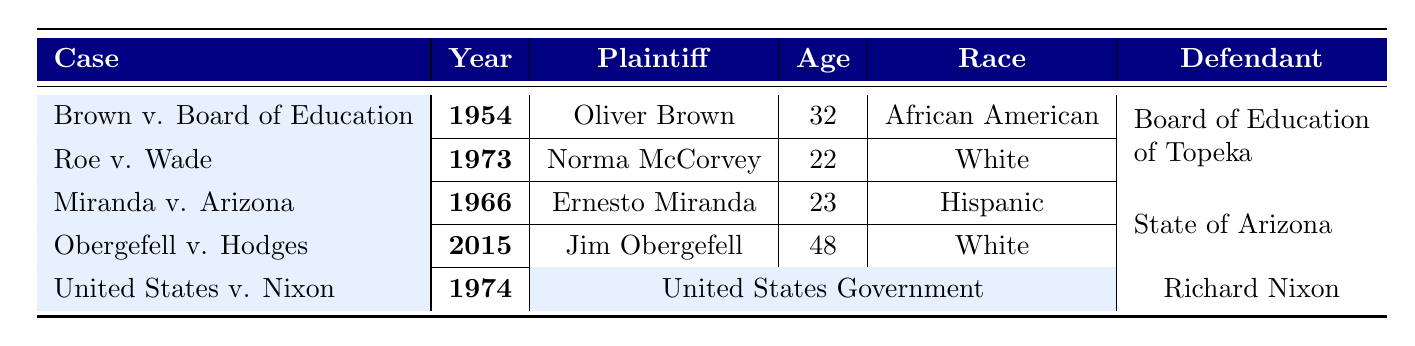What is the age of the plaintiff in Brown v. Board of Education? The table indicates Oliver Brown is the plaintiff in this case and lists his age as 32.
Answer: 32 What year did Roe v. Wade occur? The table entry for Roe v. Wade shows the year as 1973.
Answer: 1973 Which demographic has the highest minority representation among the defendants? By comparing the minority representation values of the defendants, the State of Arizona has 40%, which is higher than the other entities listed.
Answer: State of Arizona What is the race of the plaintiff in Miranda v. Arizona? The table specifies that Ernesto Miranda, the plaintiff, is categorized as Hispanic.
Answer: Hispanic How many total staff members does the Board of Education of Topeka have? The demographics section for the Board of Education of Topeka indicates that they have a total staff of 250.
Answer: 250 Which case was decided in the year with the same first digit as the plaintiff's age in that case? For Brown v. Board of Education, the plaintiff's age is 32 and the case was decided in 1954. For Roe v. Wade, the plaintiff’s age is 22 and the case was decided in 1973. Therefore, the cases that match this criterion is 'Roe v. Wade’.
Answer: Roe v. Wade Based on the table, what percentage of minority representation is higher, the United States Government or the State of Arizona? The United States Government has 40% minority representation, while the State of Arizona has 40% as well, making them equal.
Answer: Equal What occupation does the plaintiff in Obergefell v. Hodges hold? The table states that Jim Obergefell, the plaintiff in this case, is an Aerospace Engineer.
Answer: Aerospace Engineer What is the average age of the plaintiffs involved in the landmark cases? To find the average age: (32 + 22 + 23 + 48 + 0)/4 (the last entry is the United States Government, which doesn't have an age listed) = 125/4 = 31.25.
Answer: 31.25 True or False: The plaintiff in Roe v. Wade is a male. The table indicates that Norma McCorvey (Jane Roe) is the plaintiff, and she is listed as Female. Thus, the statement is false.
Answer: False How does the education level of the plaintiff in Brown v. Board of Education compare to that of the plaintiff in Miranda v. Arizona? Oliver Brown has a High School education, while Ernesto Miranda also has a High School education, making them equal in this aspect.
Answer: Equal 